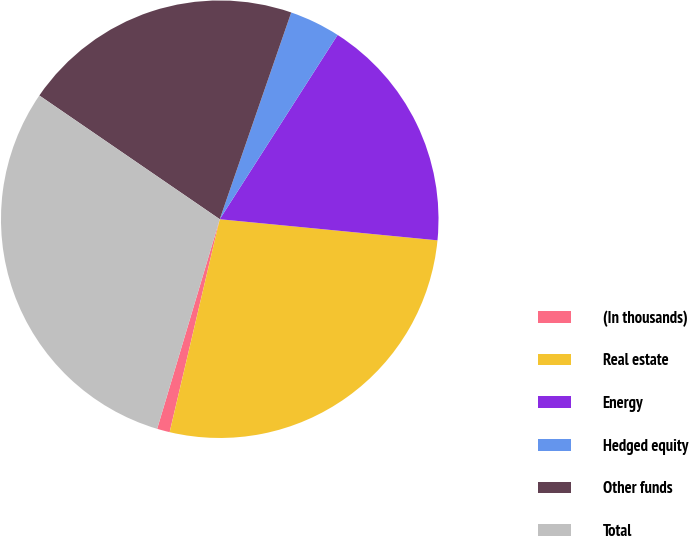Convert chart to OTSL. <chart><loc_0><loc_0><loc_500><loc_500><pie_chart><fcel>(In thousands)<fcel>Real estate<fcel>Energy<fcel>Hedged equity<fcel>Other funds<fcel>Total<nl><fcel>0.94%<fcel>27.14%<fcel>17.48%<fcel>3.76%<fcel>20.73%<fcel>29.95%<nl></chart> 